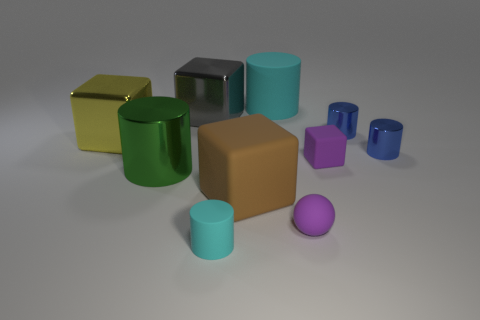Subtract all blue cylinders. How many cylinders are left? 3 Subtract 3 cubes. How many cubes are left? 1 Subtract all brown blocks. How many blocks are left? 3 Subtract all green balls. How many yellow blocks are left? 1 Subtract all balls. How many objects are left? 9 Subtract all large shiny things. Subtract all large metallic cylinders. How many objects are left? 6 Add 2 large yellow objects. How many large yellow objects are left? 3 Add 8 brown blocks. How many brown blocks exist? 9 Subtract 1 yellow blocks. How many objects are left? 9 Subtract all gray cylinders. Subtract all yellow spheres. How many cylinders are left? 5 